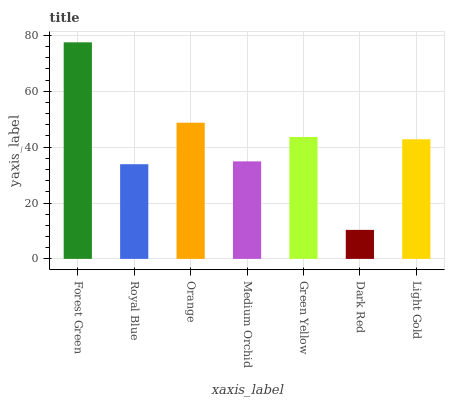Is Dark Red the minimum?
Answer yes or no. Yes. Is Forest Green the maximum?
Answer yes or no. Yes. Is Royal Blue the minimum?
Answer yes or no. No. Is Royal Blue the maximum?
Answer yes or no. No. Is Forest Green greater than Royal Blue?
Answer yes or no. Yes. Is Royal Blue less than Forest Green?
Answer yes or no. Yes. Is Royal Blue greater than Forest Green?
Answer yes or no. No. Is Forest Green less than Royal Blue?
Answer yes or no. No. Is Light Gold the high median?
Answer yes or no. Yes. Is Light Gold the low median?
Answer yes or no. Yes. Is Forest Green the high median?
Answer yes or no. No. Is Royal Blue the low median?
Answer yes or no. No. 